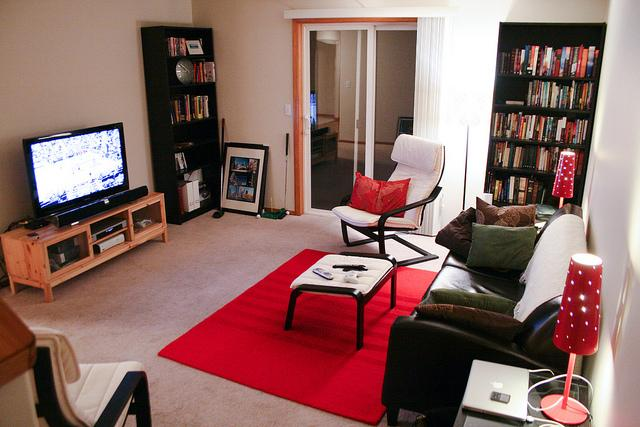What is the black couch against the wall made out of? Please explain your reasoning. leather. This is a leather couch judging by the shiny appearance of the material. 